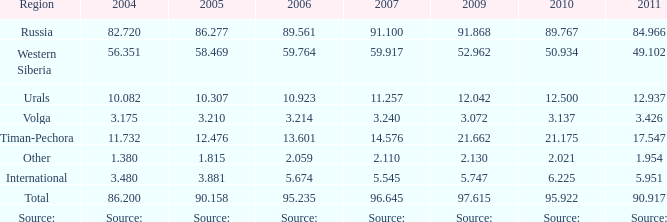545 million tonnes? 3.881. 